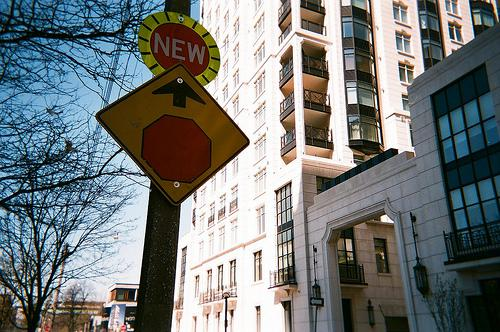Question: what is the buildings color?
Choices:
A. Red.
B. White.
C. Brown.
D. Yellow.
Answer with the letter. Answer: B Question: what color are the balcony railings?
Choices:
A. Silver.
B. White.
C. Black.
D. Brown.
Answer with the letter. Answer: C Question: how many signs are on the pole?
Choices:
A. Two.
B. One.
C. Three.
D. Four.
Answer with the letter. Answer: A Question: when was the picture taken?
Choices:
A. At night.
B. Early morning.
C. At sunset.
D. At daytime.
Answer with the letter. Answer: D 